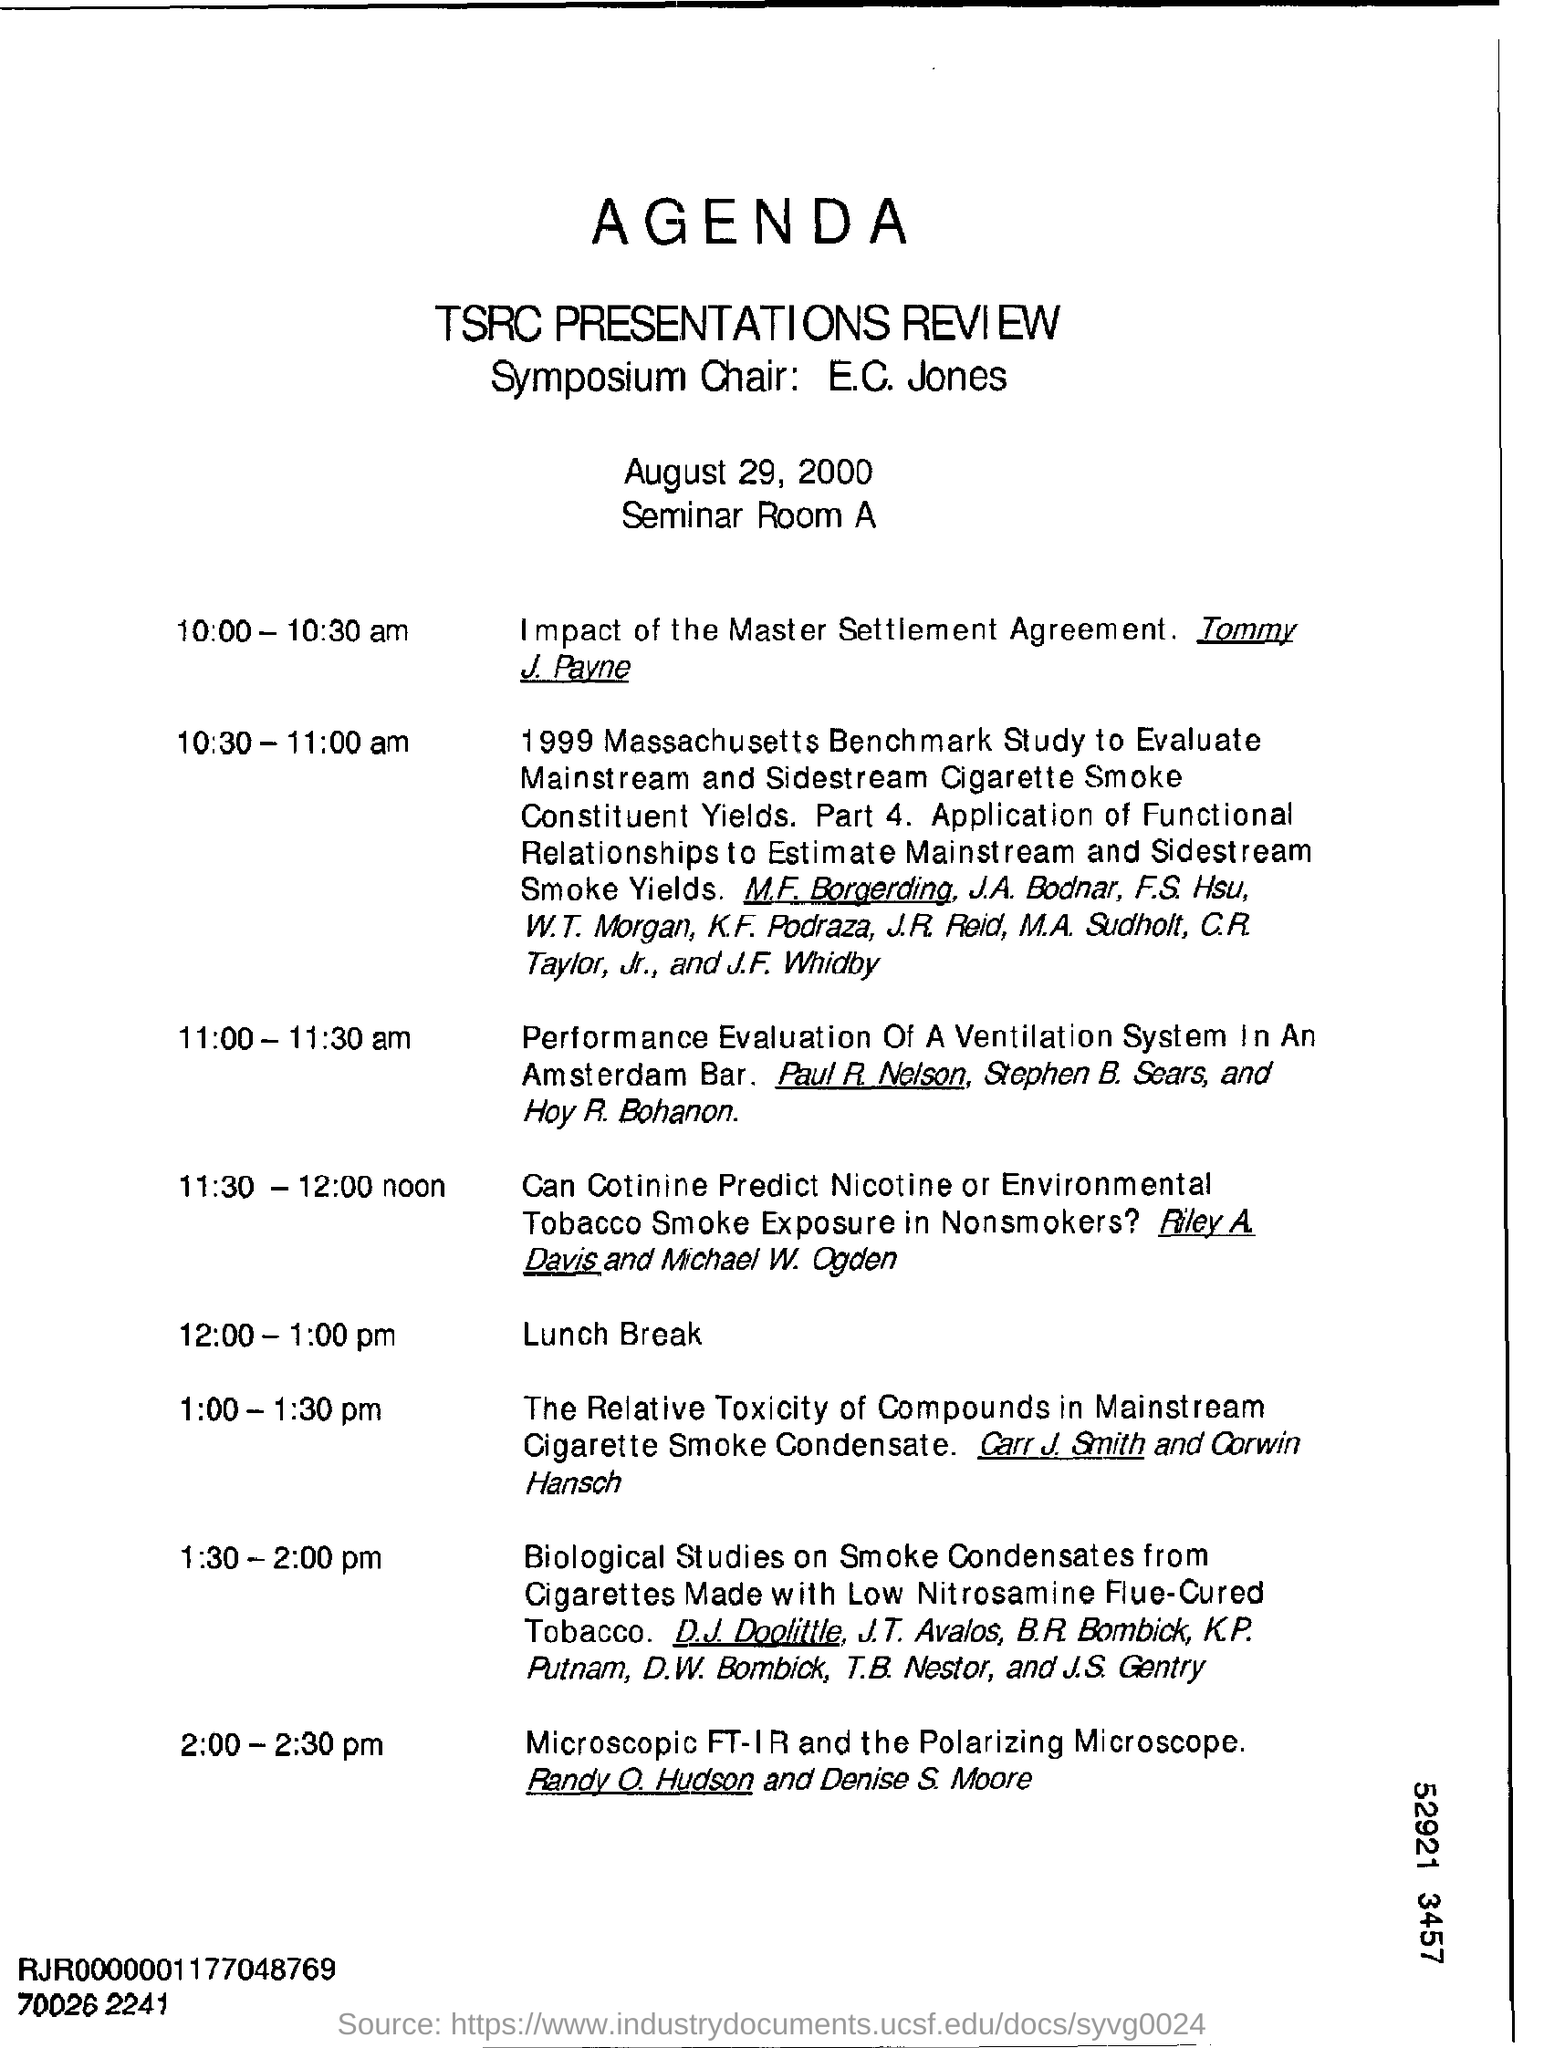What is the date mentioned ?
Your answer should be very brief. August 29, 2000. What is the item scheduled during 12:00 - 1:00 pm?
Your answer should be compact. Lunch. 